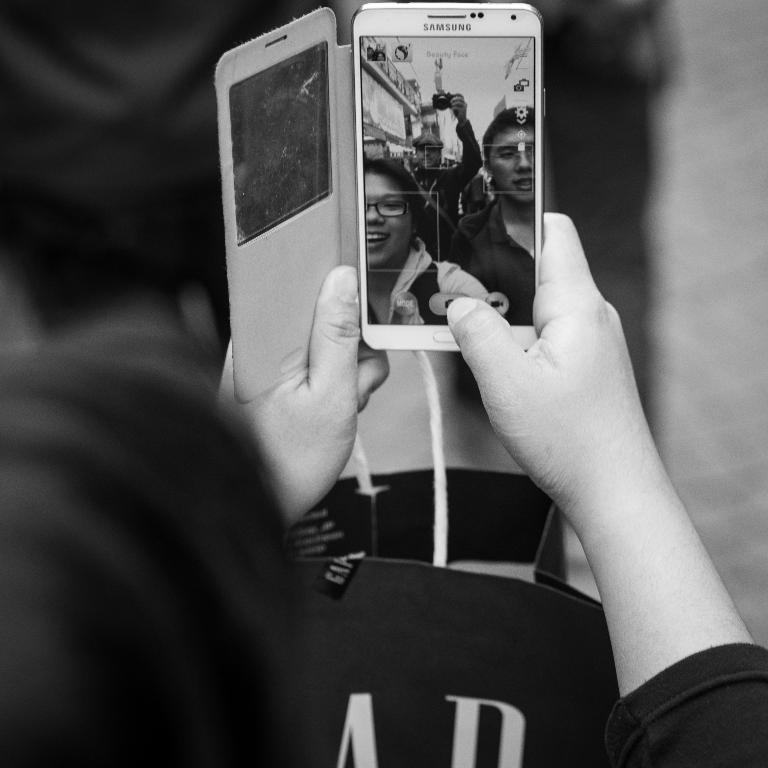Provide a one-sentence caption for the provided image. A Samsung phone is being used to take a picture. 